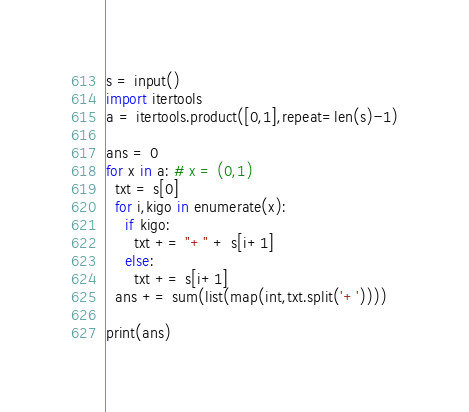<code> <loc_0><loc_0><loc_500><loc_500><_Python_>s = input()
import itertools
a = itertools.product([0,1],repeat=len(s)-1)

ans = 0
for x in a: # x = (0,1)
  txt = s[0]
  for i,kigo in enumerate(x):
    if kigo:
      txt += "+" + s[i+1]
    else:
      txt += s[i+1]
  ans += sum(list(map(int,txt.split('+'))))

print(ans)
</code> 